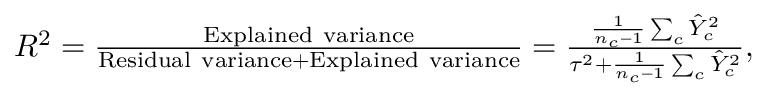Convert formula to latex. <formula><loc_0><loc_0><loc_500><loc_500>\begin{array} { r } { R ^ { 2 } = \frac { E x p l a i n e d v a r i a n c e } { R e s i d u a l v a r i a n c e + E x p l a i n e d v a r i a n c e } = \frac { \frac { 1 } { n _ { c } - 1 } \sum _ { c } \hat { Y } _ { c } ^ { 2 } } { \tau ^ { 2 } + \frac { 1 } { n _ { c } - 1 } \sum _ { c } \hat { Y } _ { c } ^ { 2 } } , } \end{array}</formula> 